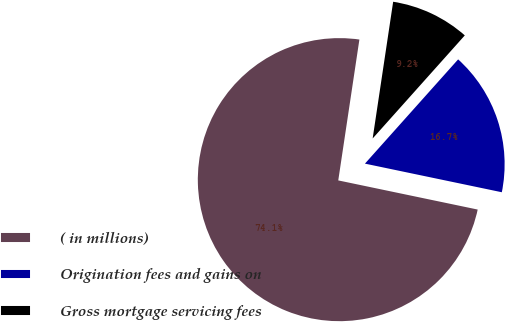Convert chart to OTSL. <chart><loc_0><loc_0><loc_500><loc_500><pie_chart><fcel>( in millions)<fcel>Origination fees and gains on<fcel>Gross mortgage servicing fees<nl><fcel>74.09%<fcel>16.67%<fcel>9.24%<nl></chart> 